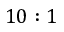Convert formula to latex. <formula><loc_0><loc_0><loc_500><loc_500>1 0 \colon 1</formula> 